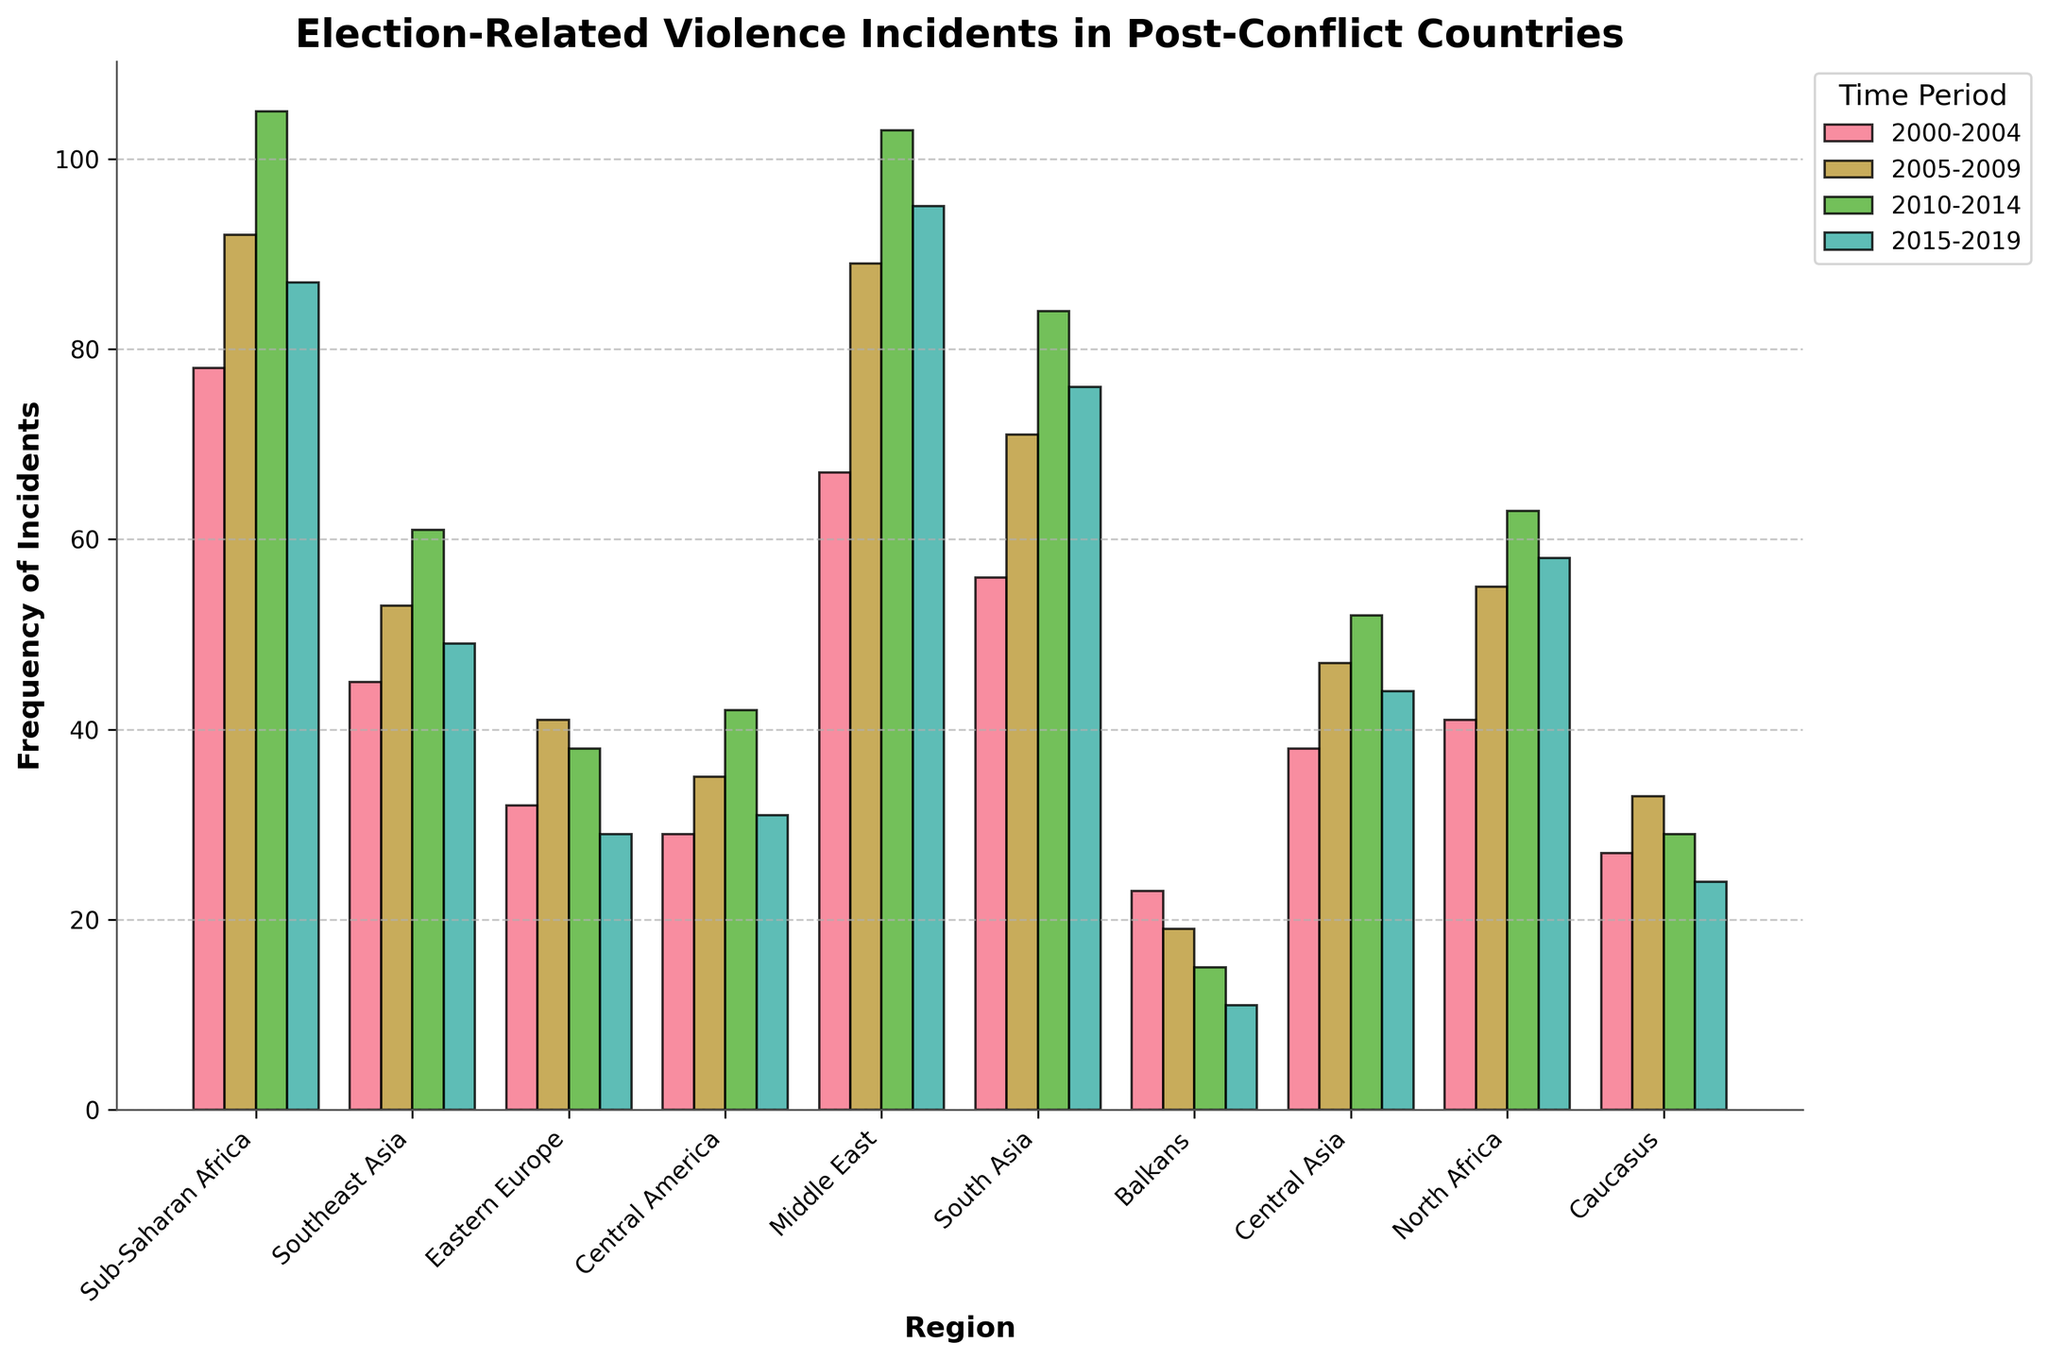Which region experienced the highest frequency of election-related violence incidents in 2010-2014? Identify the bar representing the highest frequency for 2010-2014. The Middle East bar is the tallest in this period.
Answer: Middle East Which region shows the largest decrease in election-related violence incidents from 2010-2014 to 2015-2019? Compare the height of the bars for the 2010-2014 and 2015-2019 periods. The Balkans had the most significant decline (from 15 to 11 incidents).
Answer: Balkans In which regions did the frequency of election-related violence incidents increase consistently over each period? Observe the trend for each region across all three periods to find a consistent increase. No region consistently increased in all periods.
Answer: None What is the total frequency of election-related violence incidents in Sub-Saharan Africa over the past two decades? Sum the frequencies for Sub-Saharan Africa across all periods: 78 + 92 + 105 + 87 = 362.
Answer: 362 Which two regions had the lowest frequency of election-related violence incidents in 2015-2019? Find the smallest bars in the 2015-2019 period. The Balkans and Caucasus have the lowest frequencies.
Answer: Balkans, Caucasus What is the average frequency of election-related violence incidents in Central Asia over the four periods? Sum the frequencies in Central Asia and divide by the number of periods: (38 + 47 + 52 + 44) / 4 = 45.25.
Answer: 45.25 How does the frequency of election-related violence incidents in Eastern Europe in 2015-2019 compare to that in North Africa in the same period? Compare the height of the bars for Eastern Europe and North Africa in 2015-2019. North Africa has a higher frequency than Eastern Europe (58 vs. 29).
Answer: North Africa has a higher frequency Which region experienced the most significant increase in election-related violence incidents between 2000-2004 and 2005-2009? Compare the differences for each region between these periods. The Middle East experienced the largest increase (67 to 89, increase of 22).
Answer: Middle East What is the overall trend of election-related violence in the Southeast Asia region over the two decades? Observe the series of bars for Southeast Asia. There is an increase from 2000-2004 to 2010-2014, followed by a decrease in 2015-2019.
Answer: Increase, then decrease How do the total incidents in South Asia compare to those in Southeast Asia over the two decades? Sum the frequencies for each period for both regions: South Asia (56+71+84+76 = 287), Southeast Asia (45+53+61+49 = 208). South Asia has more incidents.
Answer: South Asia has more incidents 